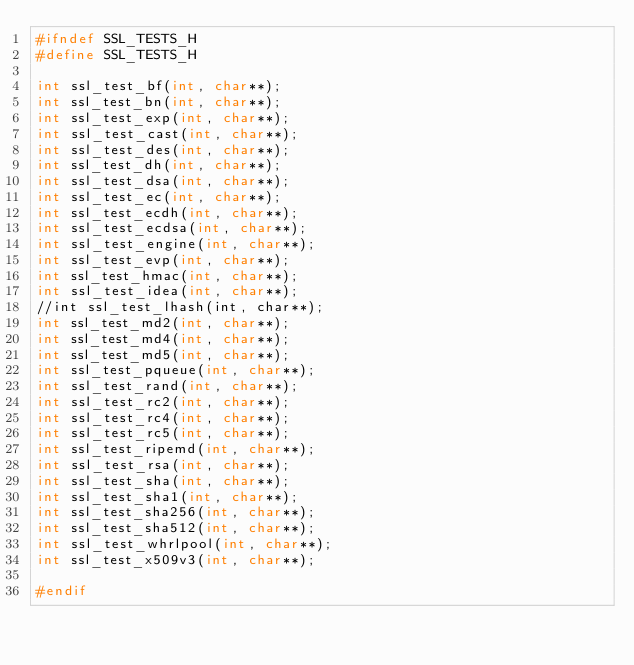Convert code to text. <code><loc_0><loc_0><loc_500><loc_500><_C_>#ifndef SSL_TESTS_H
#define SSL_TESTS_H

int ssl_test_bf(int, char**);
int ssl_test_bn(int, char**);
int ssl_test_exp(int, char**);
int ssl_test_cast(int, char**);
int ssl_test_des(int, char**);
int ssl_test_dh(int, char**);
int ssl_test_dsa(int, char**);
int ssl_test_ec(int, char**);
int ssl_test_ecdh(int, char**);
int ssl_test_ecdsa(int, char**);
int ssl_test_engine(int, char**);
int ssl_test_evp(int, char**);
int ssl_test_hmac(int, char**);
int ssl_test_idea(int, char**);
//int ssl_test_lhash(int, char**);
int ssl_test_md2(int, char**);
int ssl_test_md4(int, char**);
int ssl_test_md5(int, char**);
int ssl_test_pqueue(int, char**);
int ssl_test_rand(int, char**);
int ssl_test_rc2(int, char**);
int ssl_test_rc4(int, char**);
int ssl_test_rc5(int, char**);
int ssl_test_ripemd(int, char**);
int ssl_test_rsa(int, char**);
int ssl_test_sha(int, char**);
int ssl_test_sha1(int, char**);
int ssl_test_sha256(int, char**);
int ssl_test_sha512(int, char**);
int ssl_test_whrlpool(int, char**);
int ssl_test_x509v3(int, char**);

#endif
</code> 